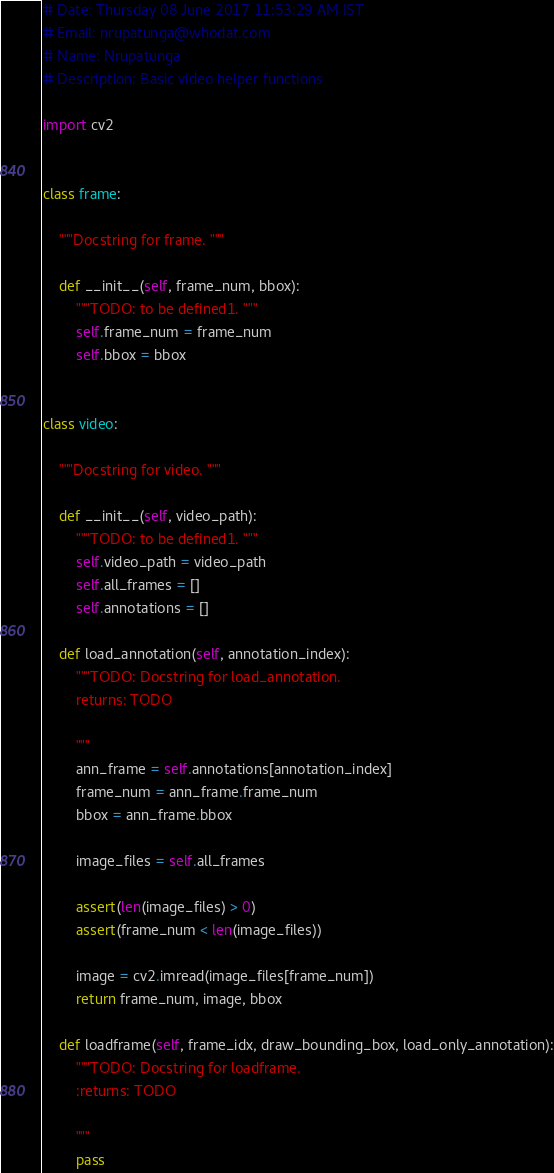<code> <loc_0><loc_0><loc_500><loc_500><_Python_># Date: Thursday 08 June 2017 11:53:29 AM IST
# Email: nrupatunga@whodat.com
# Name: Nrupatunga
# Description: Basic video helper functions

import cv2


class frame:

    """Docstring for frame. """

    def __init__(self, frame_num, bbox):
        """TODO: to be defined1. """
        self.frame_num = frame_num
        self.bbox = bbox


class video:

    """Docstring for video. """

    def __init__(self, video_path):
        """TODO: to be defined1. """
        self.video_path = video_path
        self.all_frames = []
        self.annotations = []

    def load_annotation(self, annotation_index):
        """TODO: Docstring for load_annotation.
        returns: TODO

        """
        ann_frame = self.annotations[annotation_index]
        frame_num = ann_frame.frame_num
        bbox = ann_frame.bbox

        image_files = self.all_frames

        assert(len(image_files) > 0)
        assert(frame_num < len(image_files))

        image = cv2.imread(image_files[frame_num])
        return frame_num, image, bbox

    def loadframe(self, frame_idx, draw_bounding_box, load_only_annotation):
        """TODO: Docstring for loadframe.
        :returns: TODO

        """
        pass
</code> 